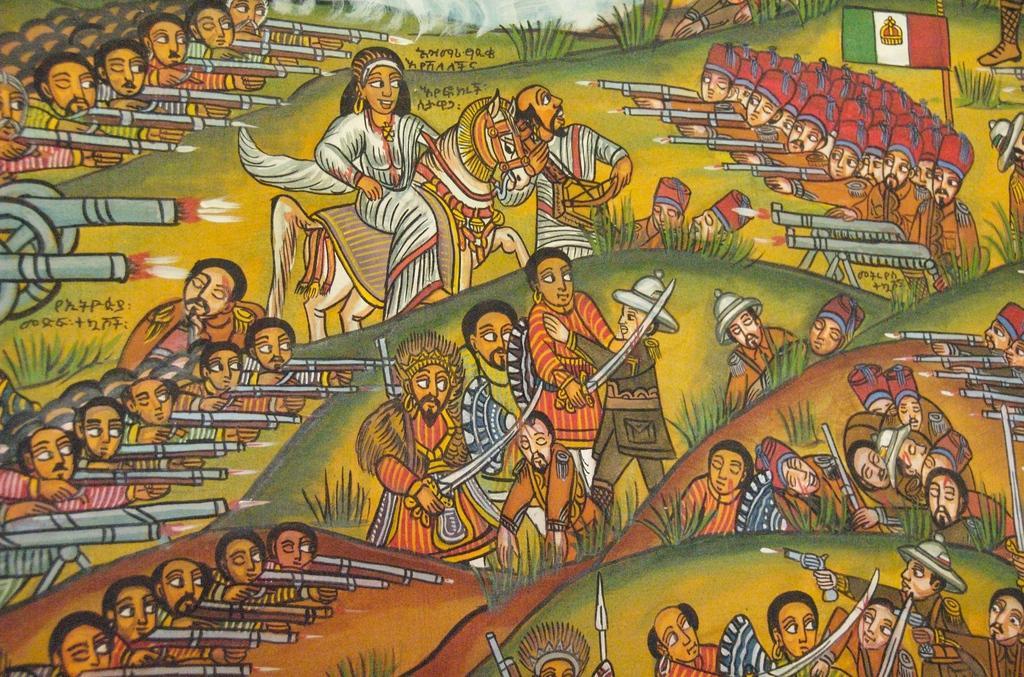Please provide a concise description of this image. In this image I can see a painting of many people. One person is sitting on a horse. Few people are holding guns and swords in the hands. There are few plants and also I can see the text. 